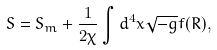Convert formula to latex. <formula><loc_0><loc_0><loc_500><loc_500>S = S _ { m } + \frac { 1 } { 2 \chi } \int d ^ { 4 } x \sqrt { - g } f ( R ) ,</formula> 